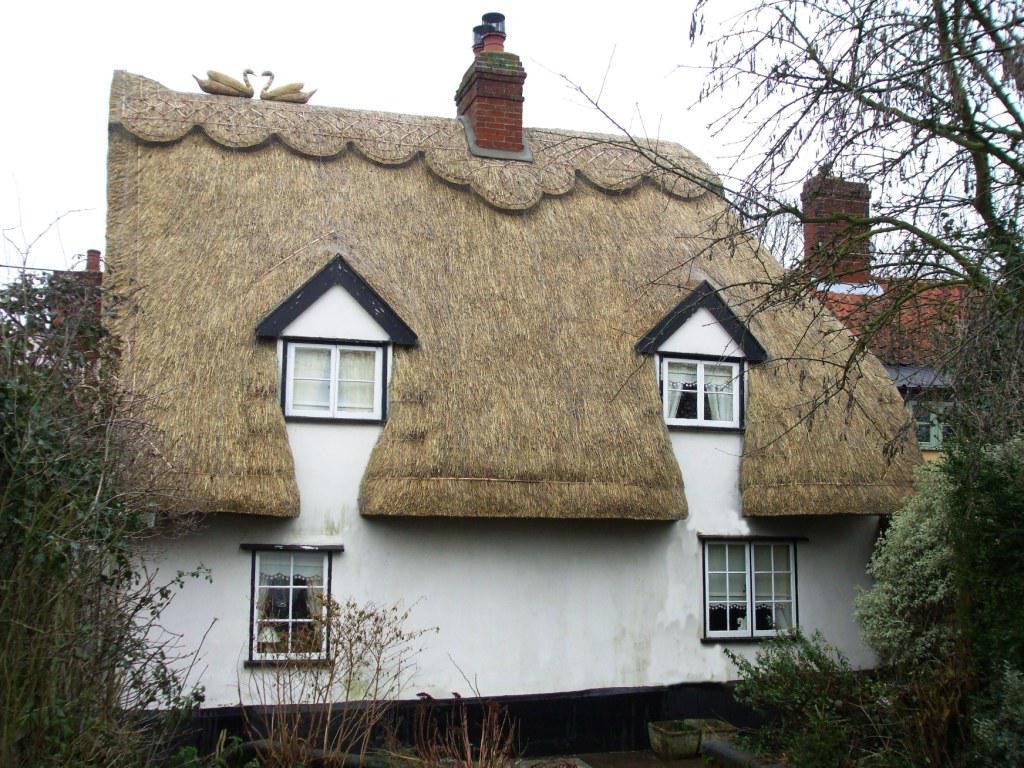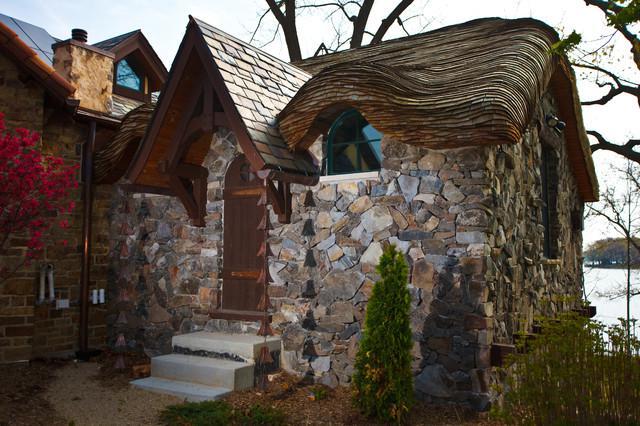The first image is the image on the left, the second image is the image on the right. Examine the images to the left and right. Is the description "there is a home with a thatch roof, fencing and flowers are next to the home" accurate? Answer yes or no. No. 